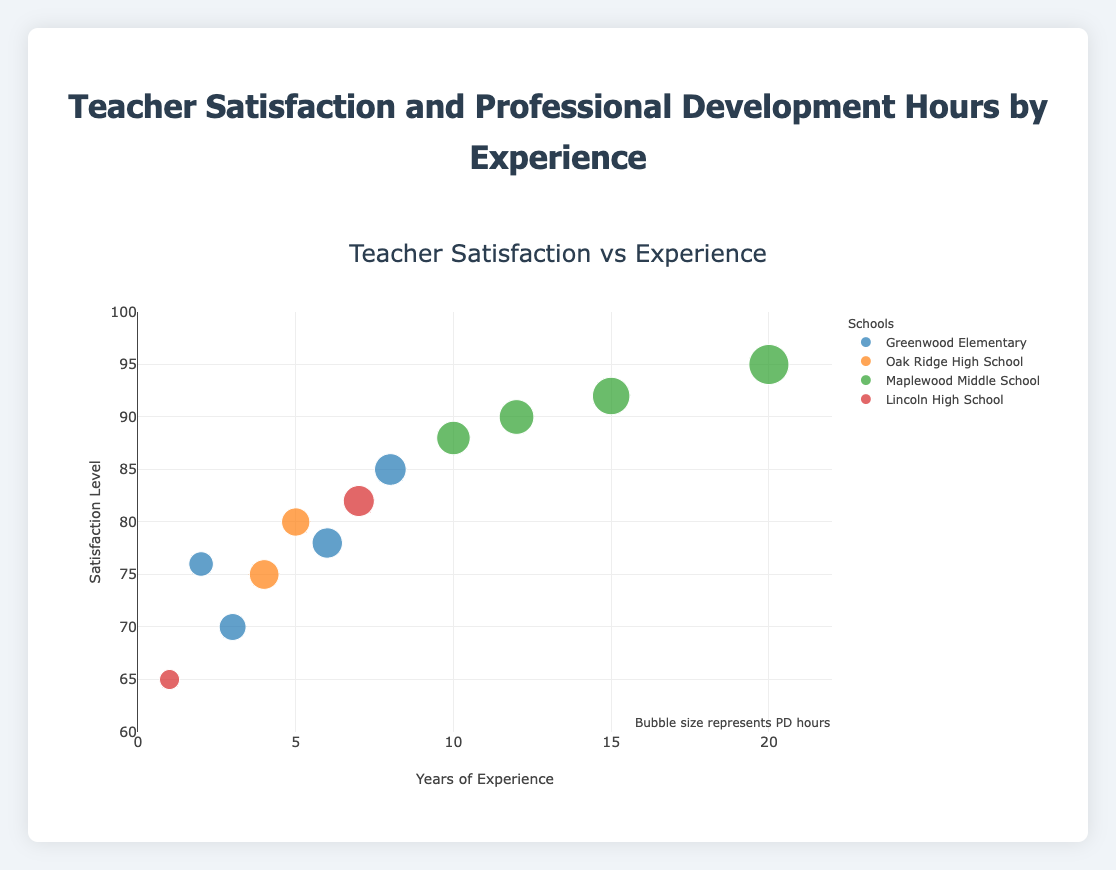How many schools are represented in the scatter plot? Identify the number of unique schools by looking at the legend of the plot, which lists all the schools.
Answer: 4 Which school has the teacher with the highest satisfaction level? Locate the point with the highest y-value (satisfaction level) and check the corresponding color or label in the legend for that school.
Answer: Maplewood Middle School What's the range of years of experience displayed on the x-axis? Look at the x-axis and identify the minimum and maximum values (usually labeled or positioned at the extremities of the axis).
Answer: 0 to 22 Which school has the largest bubble on average? Compare the sizes of the bubbles for each school by their appearance to understand the distribution of PD hours.
Answer: Maplewood Middle School How does the satisfaction level of teachers with 10 years of experience compare between different schools? Identify points on the scatter plot where experience is 10 years (x=10) and compare their y-values (satisfaction levels). Look at corresponding colors to determine the schools.
Answer: Varies by school; Maplewood Middle School has high satisfaction What is the average satisfaction level of teachers from Greenwood Elementary? Identify the points corresponding to Greenwood Elementary and calculate the average of their y-values (satisfaction levels).
Answer: (76 + 85 + 70 + 78) / 4 = 77.25 Which school has the most crowded cluster of points? Check the plot for the densest aggregation of bubbles, which can be associated with a school by color or label.
Answer: Greenwood Elementary Does higher professional development hours (PD Hours) generally correlate with higher satisfaction levels? Observe the plot for larger bubbles (representing more PD hours) and see whether they tend to lie at higher y-values.
Answer: Yes, generally Is there a teacher with more than 20 years of experience? Look at the x-axis for any points beyond 20 years of experience.
Answer: Yes Do teachers with less experience generally have lower satisfaction levels? Examine the points on the left side of the x-axis (lower years of experience) and check if they tend to have lower y-values (satisfaction levels).
Answer: Yes, generally 